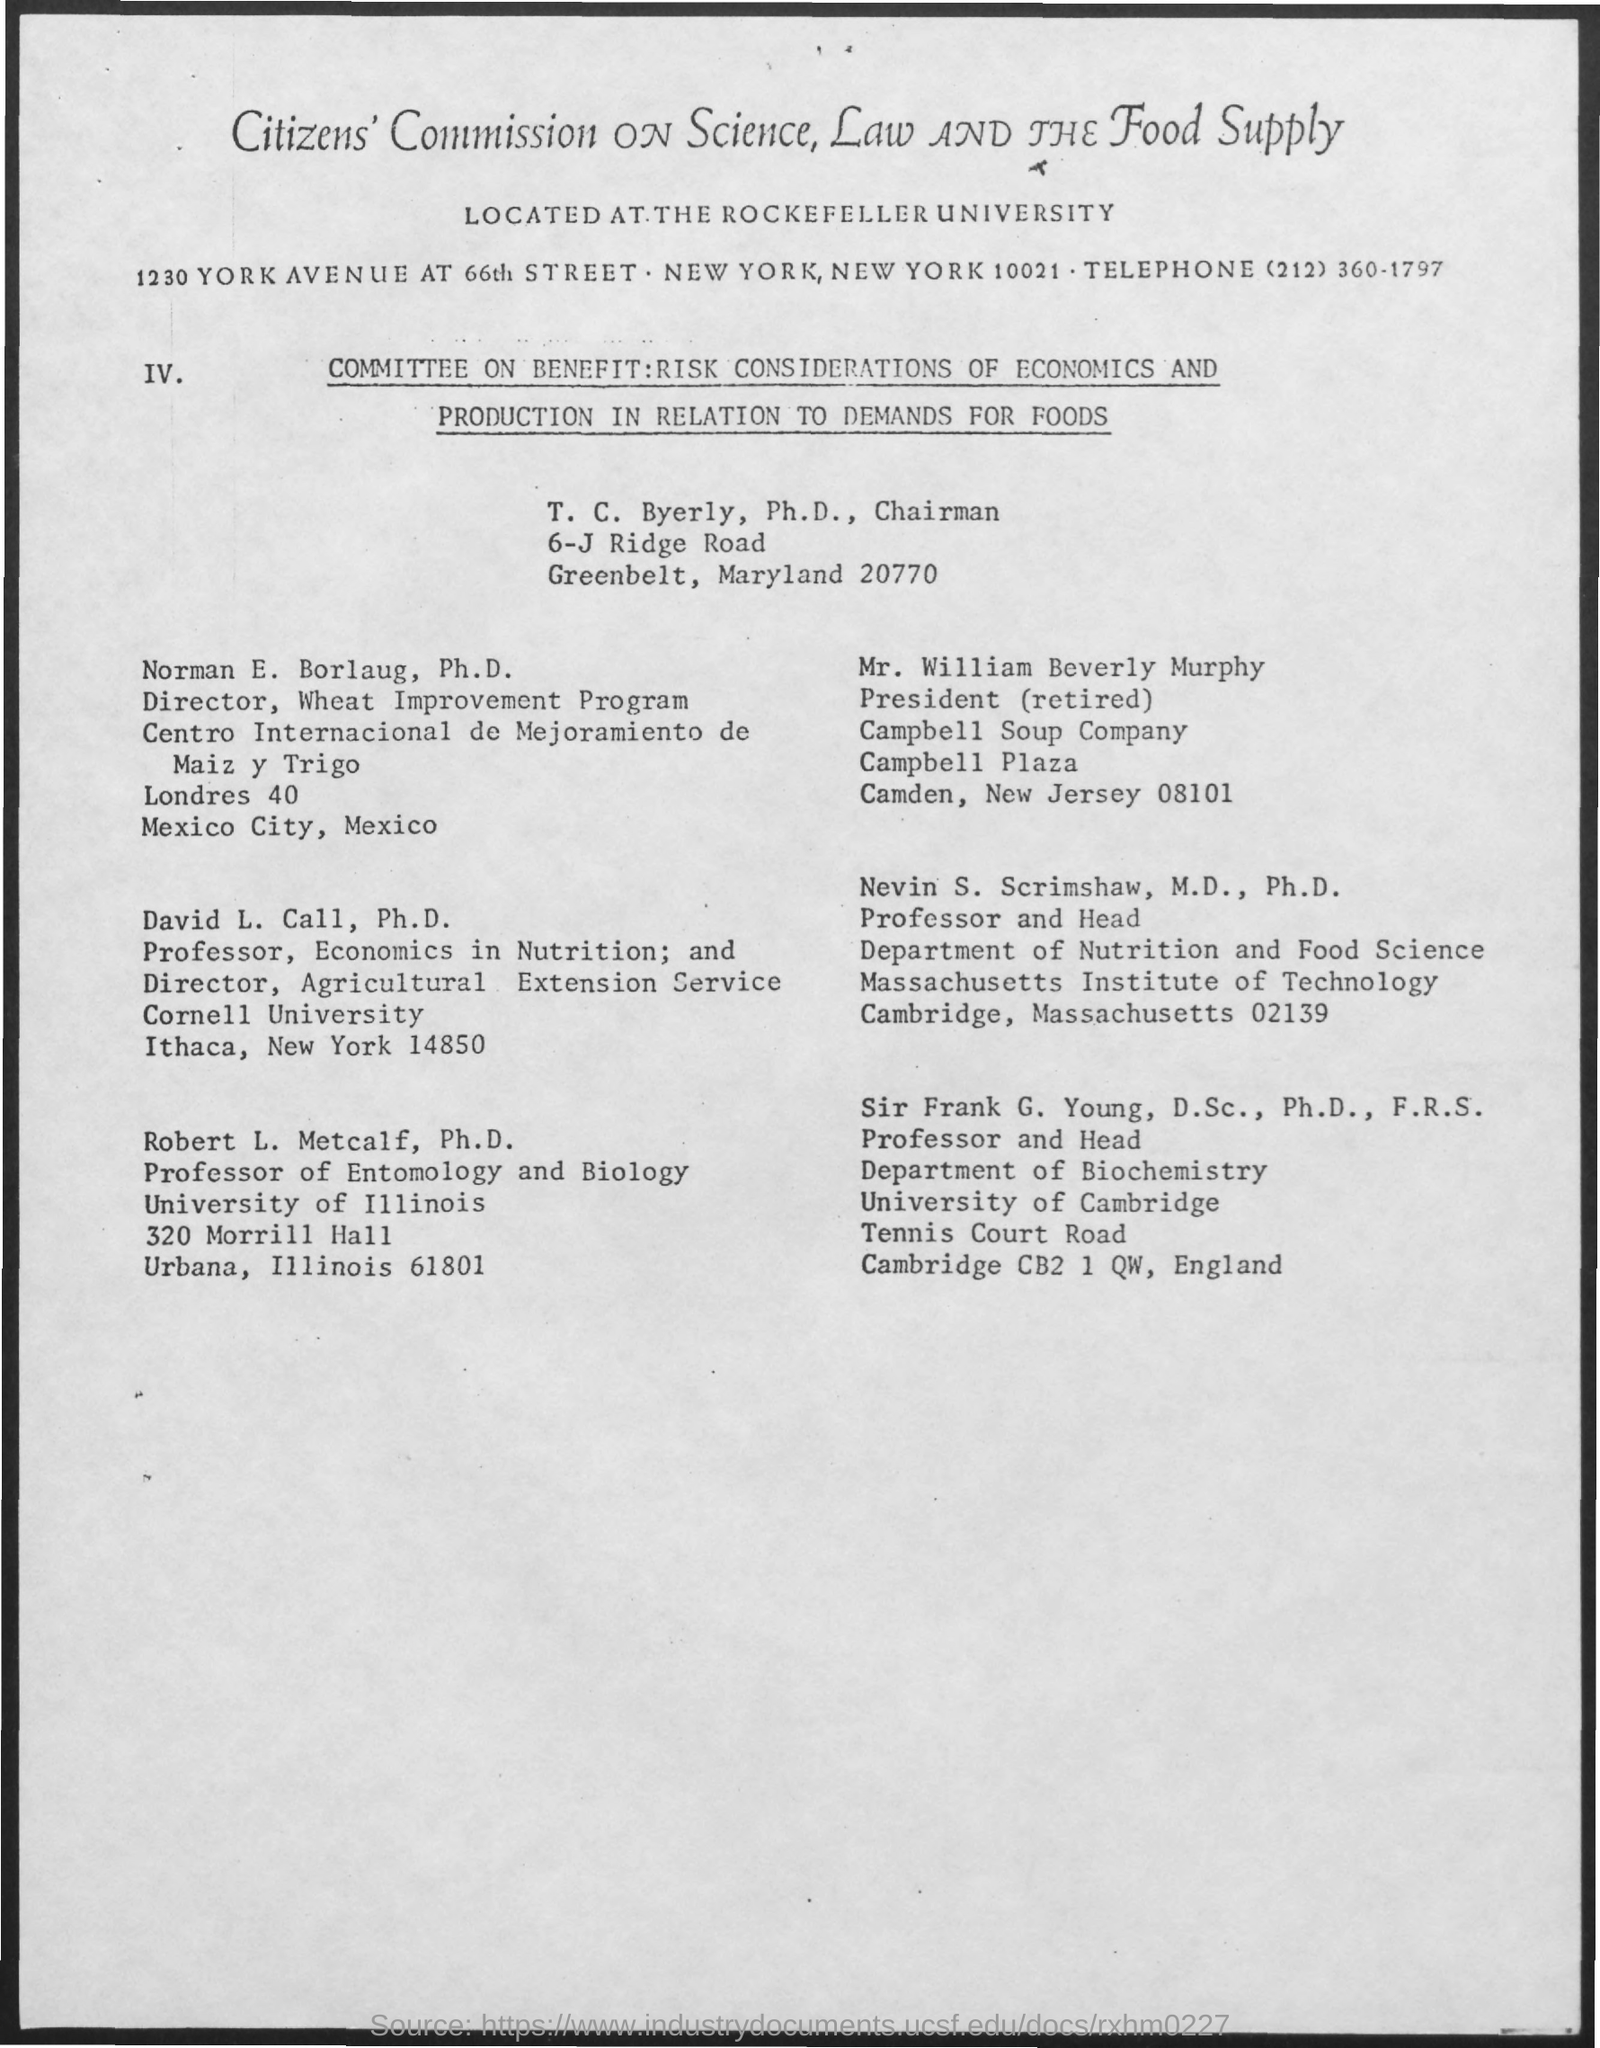What is the name of the university mentioned in the given form ?
Provide a succinct answer. Rockefeller university. What is the telephone no. mentioned ?
Your answer should be compact. (212) 360-1797. What is the designation of mr. william beverly murphy ?
Give a very brief answer. President (retired). 